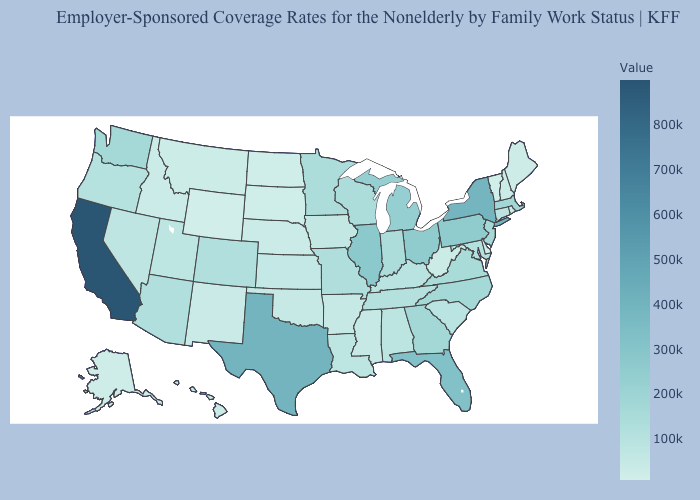Does New Hampshire have the highest value in the USA?
Quick response, please. No. Which states have the lowest value in the MidWest?
Concise answer only. North Dakota. Is the legend a continuous bar?
Keep it brief. Yes. Which states have the lowest value in the MidWest?
Give a very brief answer. North Dakota. Among the states that border California , which have the highest value?
Quick response, please. Arizona. Does Delaware have the lowest value in the South?
Keep it brief. Yes. Does the map have missing data?
Be succinct. No. Which states have the lowest value in the USA?
Write a very short answer. Wyoming. 